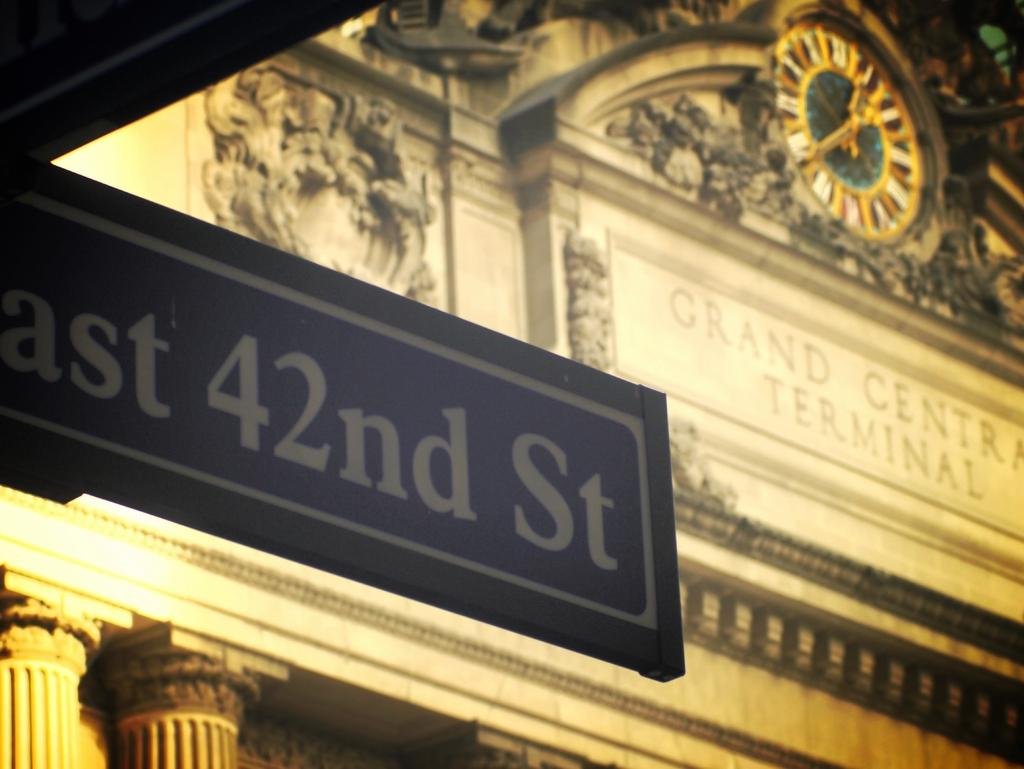<image>
Create a compact narrative representing the image presented. AN East 42nd street sign is in front of the Grand Central Terminal 